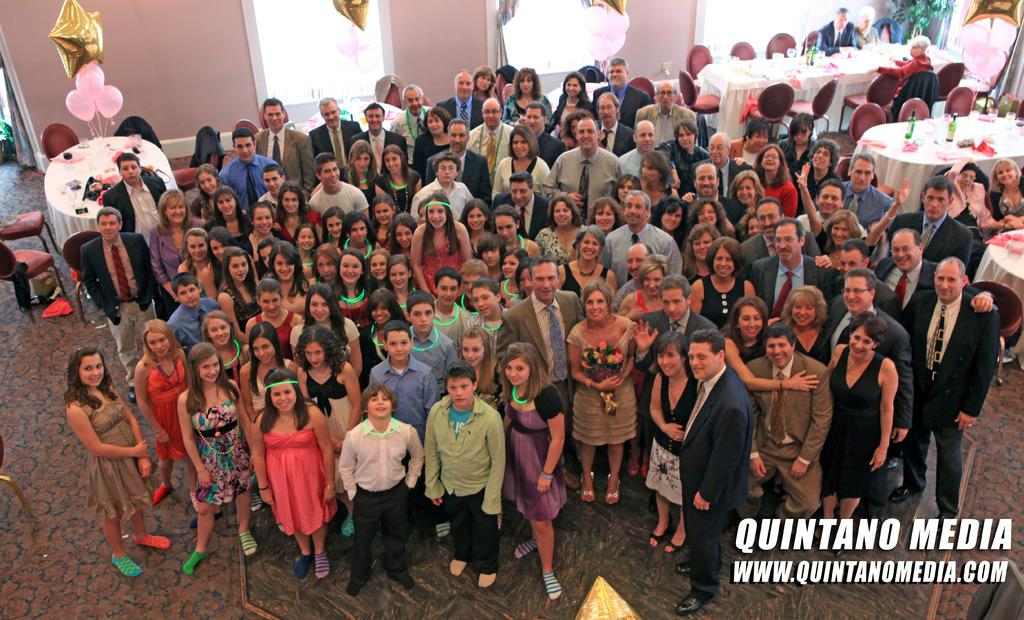What are the people in the image doing? The people in the image are standing and posing for a photo. What can be seen behind the people in the image? There are tables and chairs behind the people in the image. What is visible in the background of the image? There are windows in the background of the image. Can you tell me how much profit the pet is making in the image? There is no pet or mention of profit in the image; it features people posing for a photo with tables, chairs, and windows in the background. 